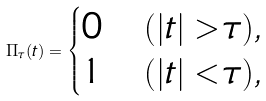Convert formula to latex. <formula><loc_0><loc_0><loc_500><loc_500>\Pi _ { \tau } ( t ) = \begin{cases} 0 & ( | t | > \tau ) , \\ 1 & ( | t | < \tau ) , \end{cases}</formula> 